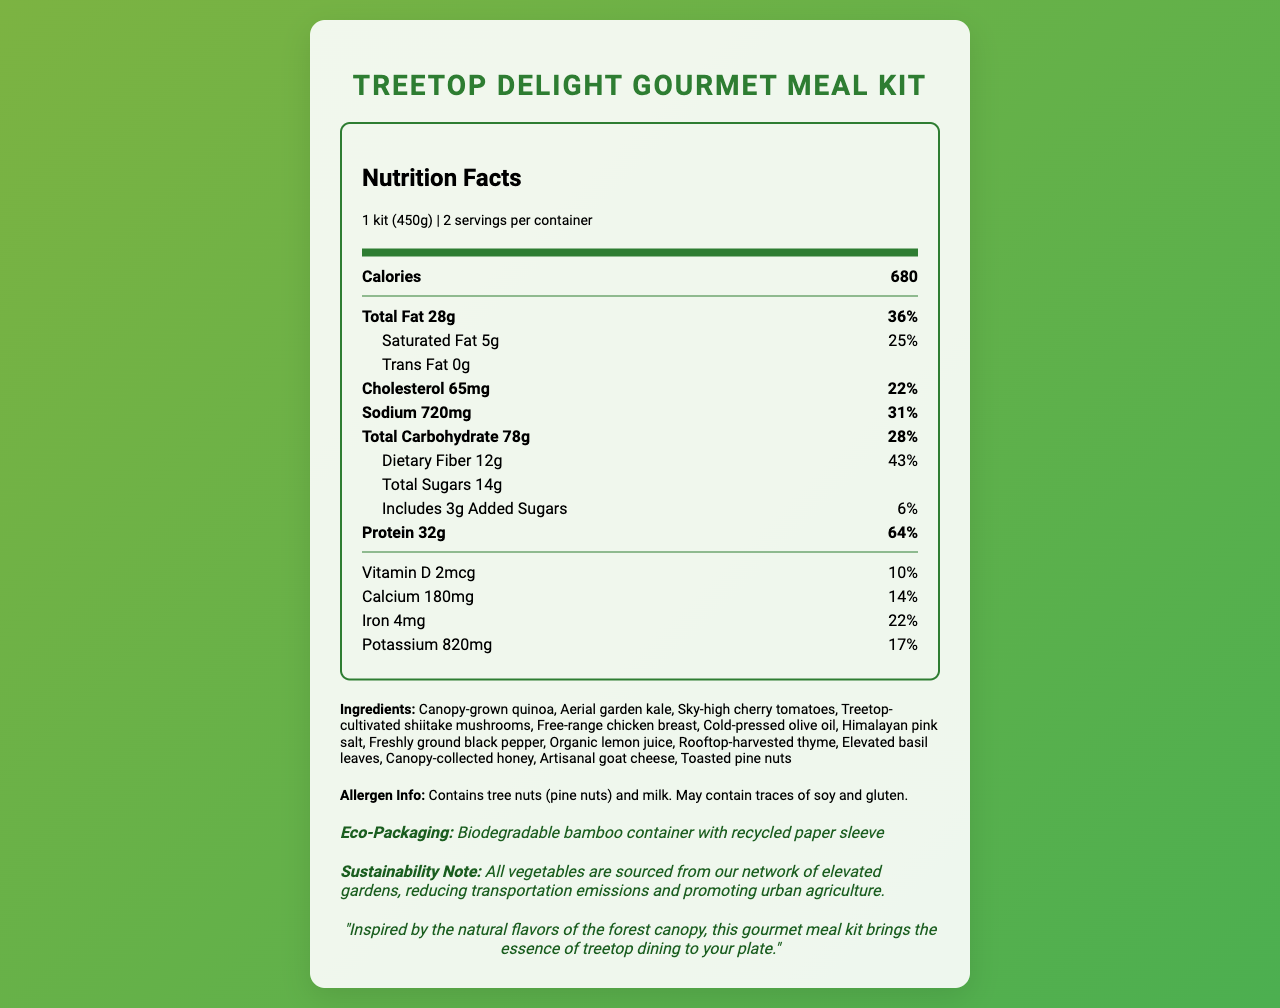what is the serving size of the Treetop Delight Gourmet Meal Kit? The serving size is mentioned at the top of the nutrition label under the product name.
Answer: 1 kit (450g) how many servings are there per container? The servings per container information is provided right below the serving size in the nutrition label.
Answer: 2 how many calories are there per serving? The calorie count is listed prominently in the main nutrition facts section.
Answer: 680 what is the total fat content in the meal kit? The total fat content is listed under the nutrition facts, mentioning "Total Fat 28g".
Answer: 28g how much dietary fiber does the meal kit contain? The dietary fiber content is listed under the "Total Carbohydrate" section.
Answer: 12g how much sodium is present in the meal? The sodium content is mentioned in the nutrition label under "Sodium".
Answer: 720mg what are the ingredients of the Treetop Delight Gourmet Meal Kit? The ingredients are listed under the "Ingredients" section near the bottom of the document.
Answer: Canopy-grown quinoa, Aerial garden kale, Sky-high cherry tomatoes, Treetop-cultivated shiitake mushrooms, Free-range chicken breast, Cold-pressed olive oil, Himalayan pink salt, Freshly ground black pepper, Organic lemon juice, Rooftop-harvested thyme, Elevated basil leaves, Canopy-collected honey, Artisanal goat cheese, Toasted pine nuts does the meal kit contain any allergens? The allergen information is provided in the "Allergen Info" section and specifies the presence of tree nuts (pine nuts) and milk.
Answer: Yes what material is used for the eco-packaging? The eco-packaging detail is mentioned in the "Eco-Packaging" section.
Answer: Biodegradable bamboo container with recycled paper sleeve what is the percentage of daily value (% DV) of protein provided per serving? The daily value percentage for protein is given in the nutrition facts under "Protein".
Answer: 64% how much calcium is in a serving of the Treetop Delight Gourmet Meal Kit? A. 100mg B. 180mg C. 200mg D. 250mg The calcium content is listed under the nutrition facts section with its amount and daily value percentage.
Answer: B. 180mg which of the following ingredients are NOT included in the meal kit? A. Canopy-grown quinoa B. Sky-high cherry tomatoes C. Treetop-cultivated shiitake mushrooms D. Ground beef The ingredient list includes all other options, but not ground beef.
Answer: D. Ground beef is the meal kit environmentally sustainable? The sustainability note mentions that the meal kit sources vegetables from elevated gardens, reducing transportation emissions and promoting urban agriculture.
Answer: Yes provide a summary of the Treetop Delight Gourmet Meal Kit document. The summary covers all major parts of the document, including serving information, nutritional details, ingredients, allergen info, eco-packaging, and sustainability notes.
Answer: The document provides a detailed nutrition facts label for the "Treetop Delight Gourmet Meal Kit," showcasing a serving size of 450g and 2 servings per container. The meal kit contains 680 calories per serving, with detailed breakdowns of fat, cholesterol, sodium, carbohydrates, fiber, sugars, and protein. Ingredients are sourced from elevated gardens, and the meal kit is packaged in biodegradable materials. Allergen information is also provided. The document emphasizes eco-friendliness and sustainability. what is the source of the quinoa used in the kit? The document does not provide information about where the canopy-grown quinoa is specifically sourced from.
Answer: Cannot be determined 